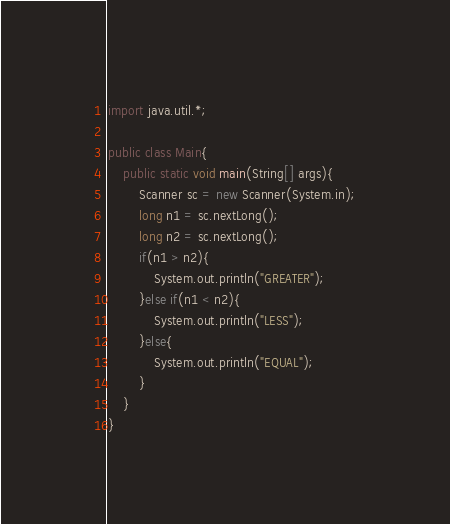<code> <loc_0><loc_0><loc_500><loc_500><_Java_>import java.util.*;
 
public class Main{
	public static void main(String[] args){
    	Scanner sc = new Scanner(System.in);
        long n1 = sc.nextLong();
        long n2 = sc.nextLong();
        if(n1 > n2){
        	System.out.println("GREATER");
        }else if(n1 < n2){
        	System.out.println("LESS");
        }else{
        	System.out.println("EQUAL");
        }
    }
}</code> 